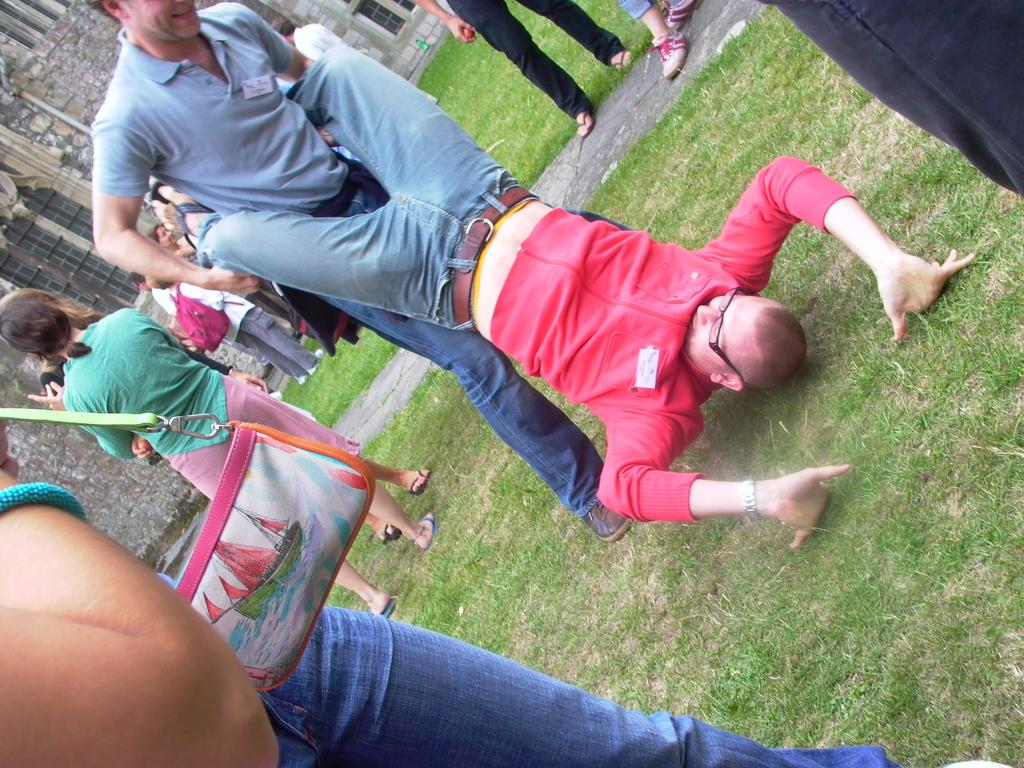How many people are present in the image? The number of people cannot be determined from the provided facts, as it only states that there are people in the image. What are the people doing in the image? The people are doing different activities in the image. Where are the activities taking place? The activities are taking place on a ground. What can be seen in the background of the image? There is a building in the background of the image. What type of pear is hanging from the frame in the image? There is no pear or frame present in the image. 